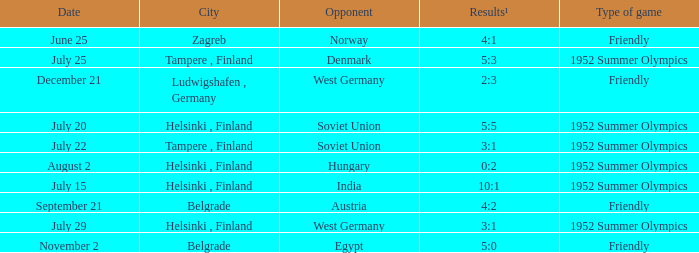What Type of game was played on Date of July 29? 1952 Summer Olympics. 